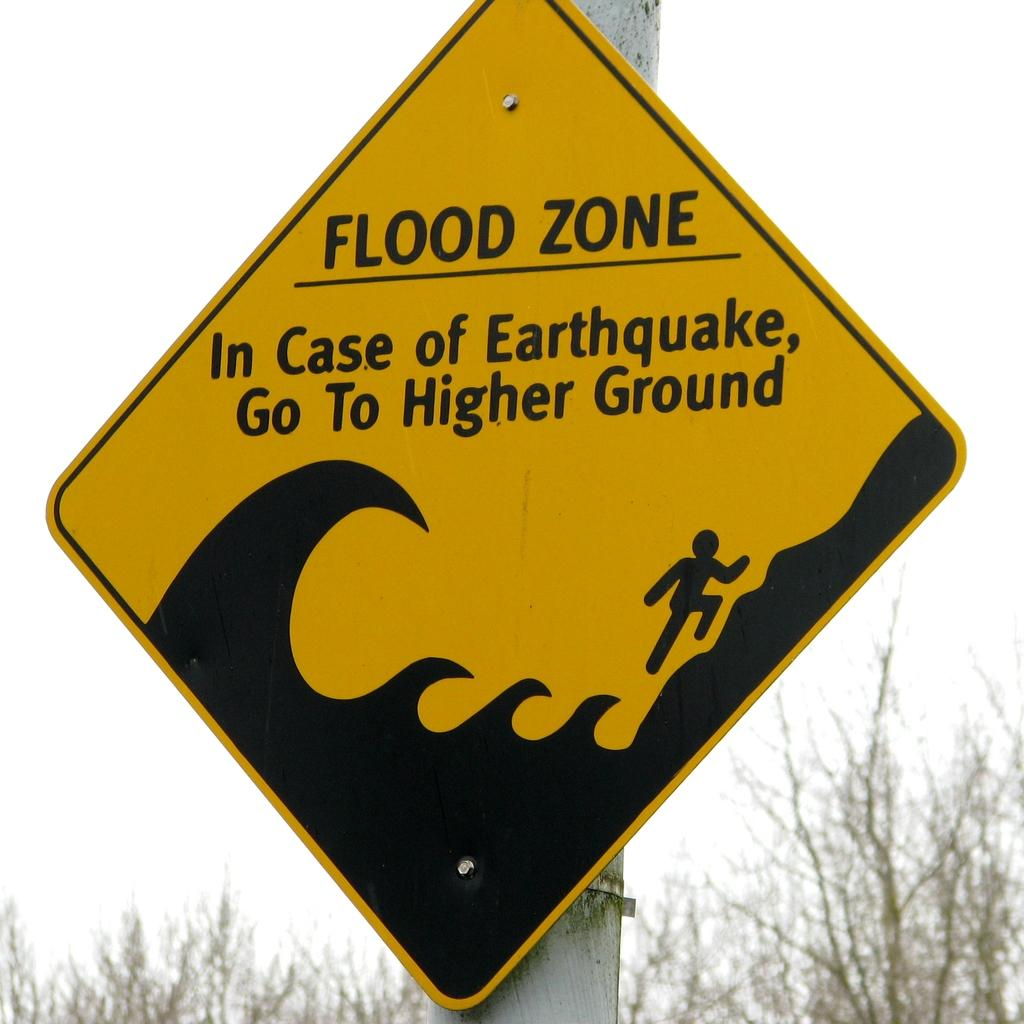<image>
Summarize the visual content of the image. a yellow and black street sign warning of a flood zone 